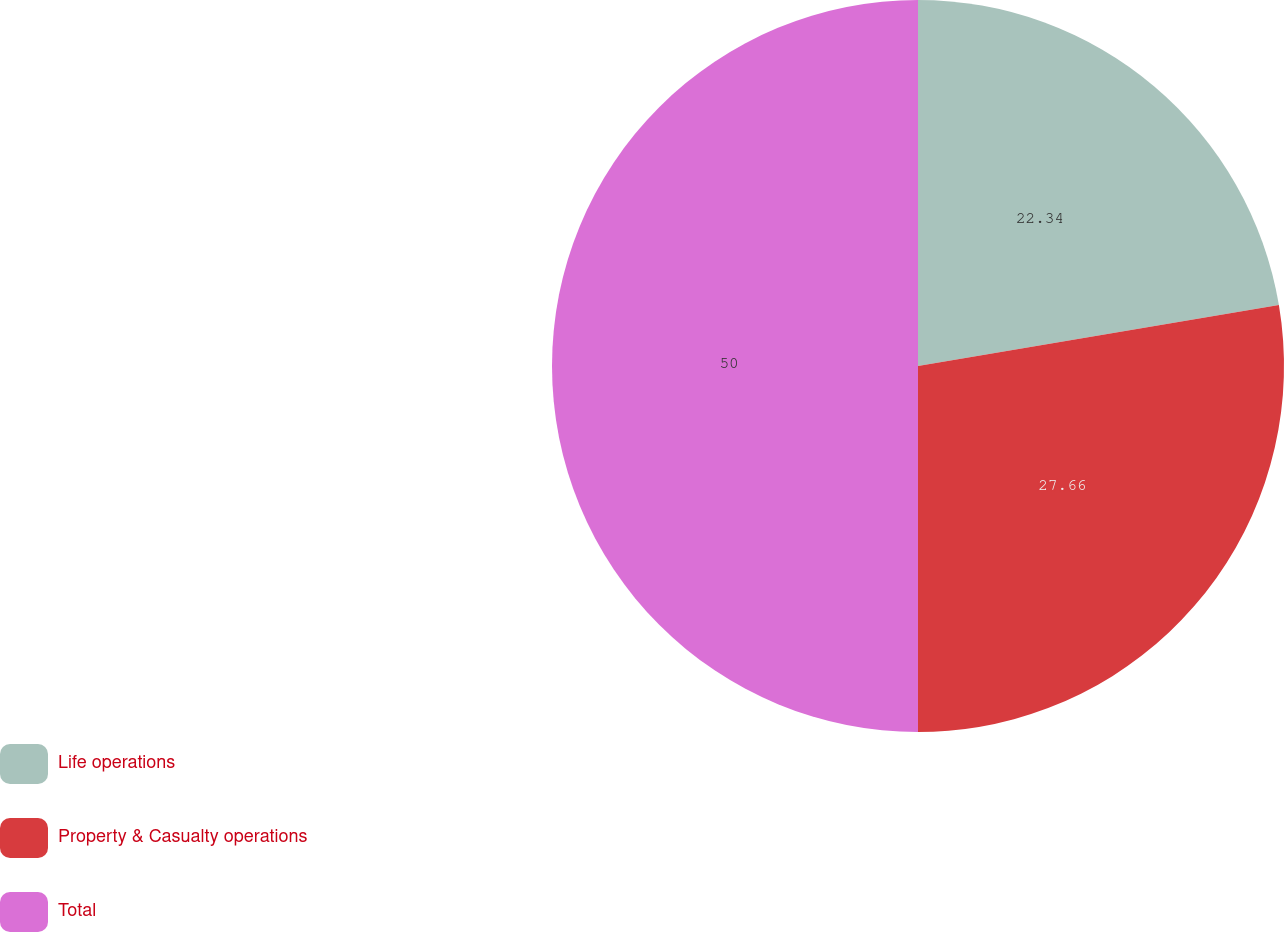<chart> <loc_0><loc_0><loc_500><loc_500><pie_chart><fcel>Life operations<fcel>Property & Casualty operations<fcel>Total<nl><fcel>22.34%<fcel>27.66%<fcel>50.0%<nl></chart> 